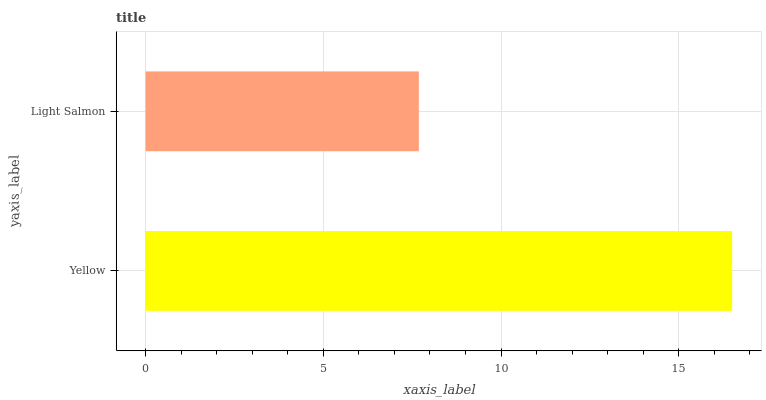Is Light Salmon the minimum?
Answer yes or no. Yes. Is Yellow the maximum?
Answer yes or no. Yes. Is Light Salmon the maximum?
Answer yes or no. No. Is Yellow greater than Light Salmon?
Answer yes or no. Yes. Is Light Salmon less than Yellow?
Answer yes or no. Yes. Is Light Salmon greater than Yellow?
Answer yes or no. No. Is Yellow less than Light Salmon?
Answer yes or no. No. Is Yellow the high median?
Answer yes or no. Yes. Is Light Salmon the low median?
Answer yes or no. Yes. Is Light Salmon the high median?
Answer yes or no. No. Is Yellow the low median?
Answer yes or no. No. 